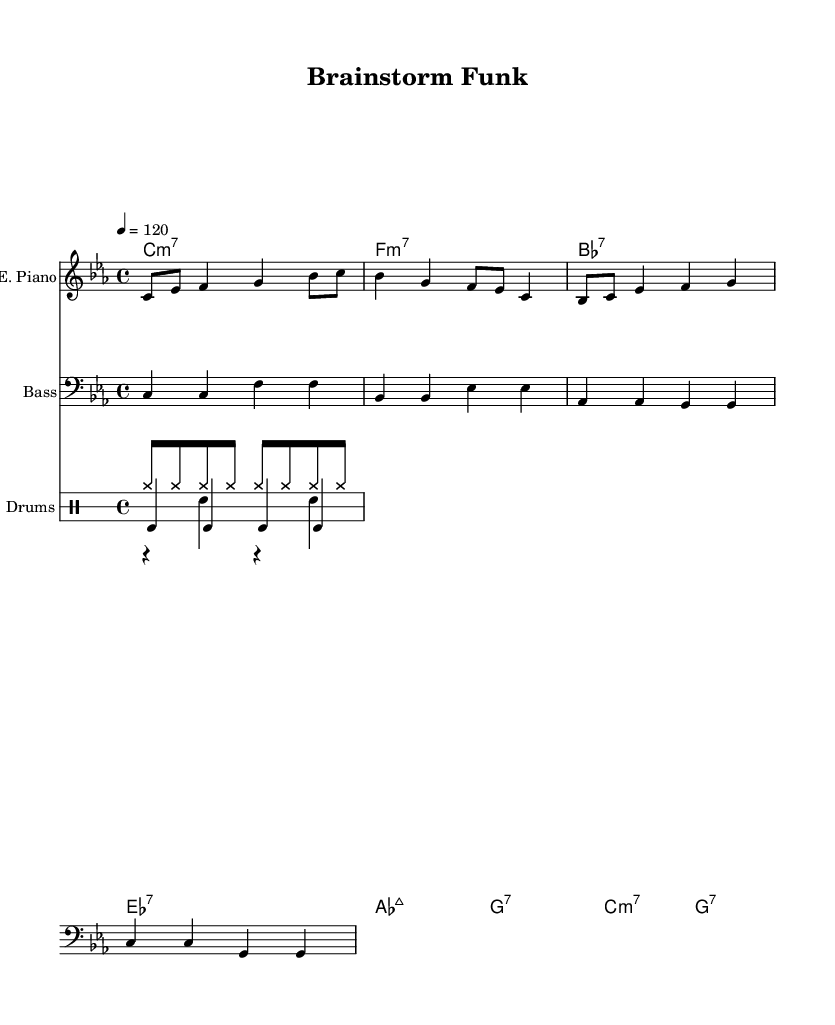What is the key signature of this music? The key signature is C minor, which is indicated by the four flats (B♭, E♭, A♭, and D♭) in the music.
Answer: C minor What is the time signature of this piece? The time signature is indicated by the "4/4" at the beginning of the score, which means there are 4 beats in each measure and a quarter note gets one beat.
Answer: 4/4 What is the tempo marking for this composition? The tempo marking is indicated by "4 = 120", meaning that there are 120 beats per minute, where the quarter note (4) gets the beat.
Answer: 120 Which instruments are used in this composition? The instruments are identified in the score under each staff: Electric Piano, Bass, and Drums.
Answer: Electric Piano, Bass, Drums How many measures are present in the electric piano part? To find the number of measures, we count the distinct sets of bars in the electric piano staff; there are 4 measures in total.
Answer: 4 Which chord is played in the first measure? The first measure contains a C minor 7 chord, indicated at the start of the chord names section, showing the chord structure above the music notation.
Answer: C minor 7 What is the rhythmic pattern of the hi-hat in the drums section? The hi-hat's pattern is represented as eight consecutive eighth notes, and since there are no rests, it plays continuously through the measure.
Answer: Continuous eighth notes 